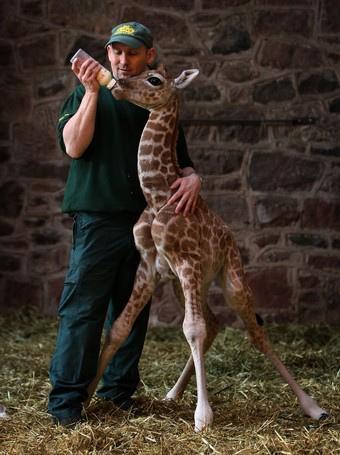How many people can be seen?
Give a very brief answer. 1. How many boats are shown?
Give a very brief answer. 0. 